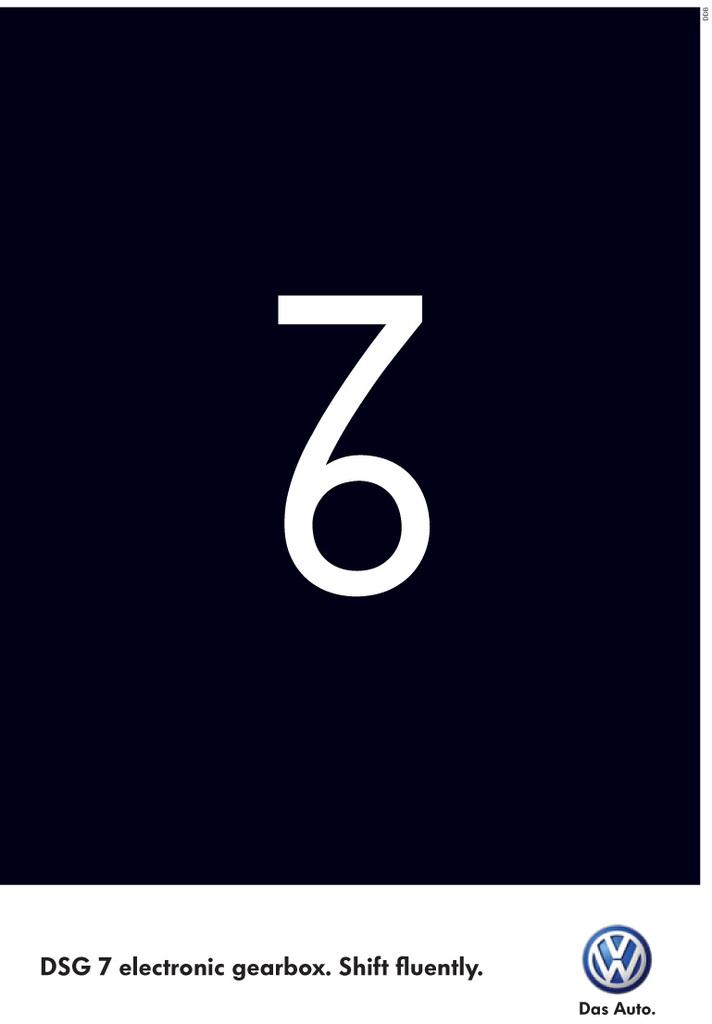What numbers are combined in the middle?
Offer a terse response. 76. 